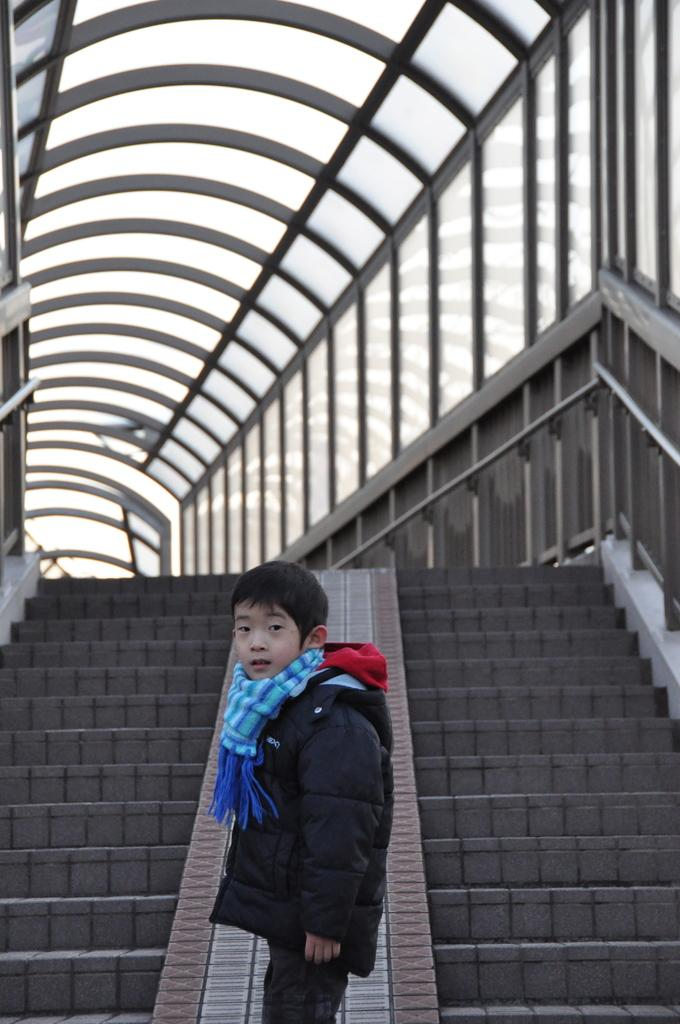What is the main subject of the image? The main subject of the image is a kid. Where is the kid located in the image? The kid is standing near the stairs. What can be seen on the right side of the image? There is a railing on the right side of the image. What type of linen is being used to cover the kid in the image? There is no linen present in the image, and the kid is not covered by any fabric. 